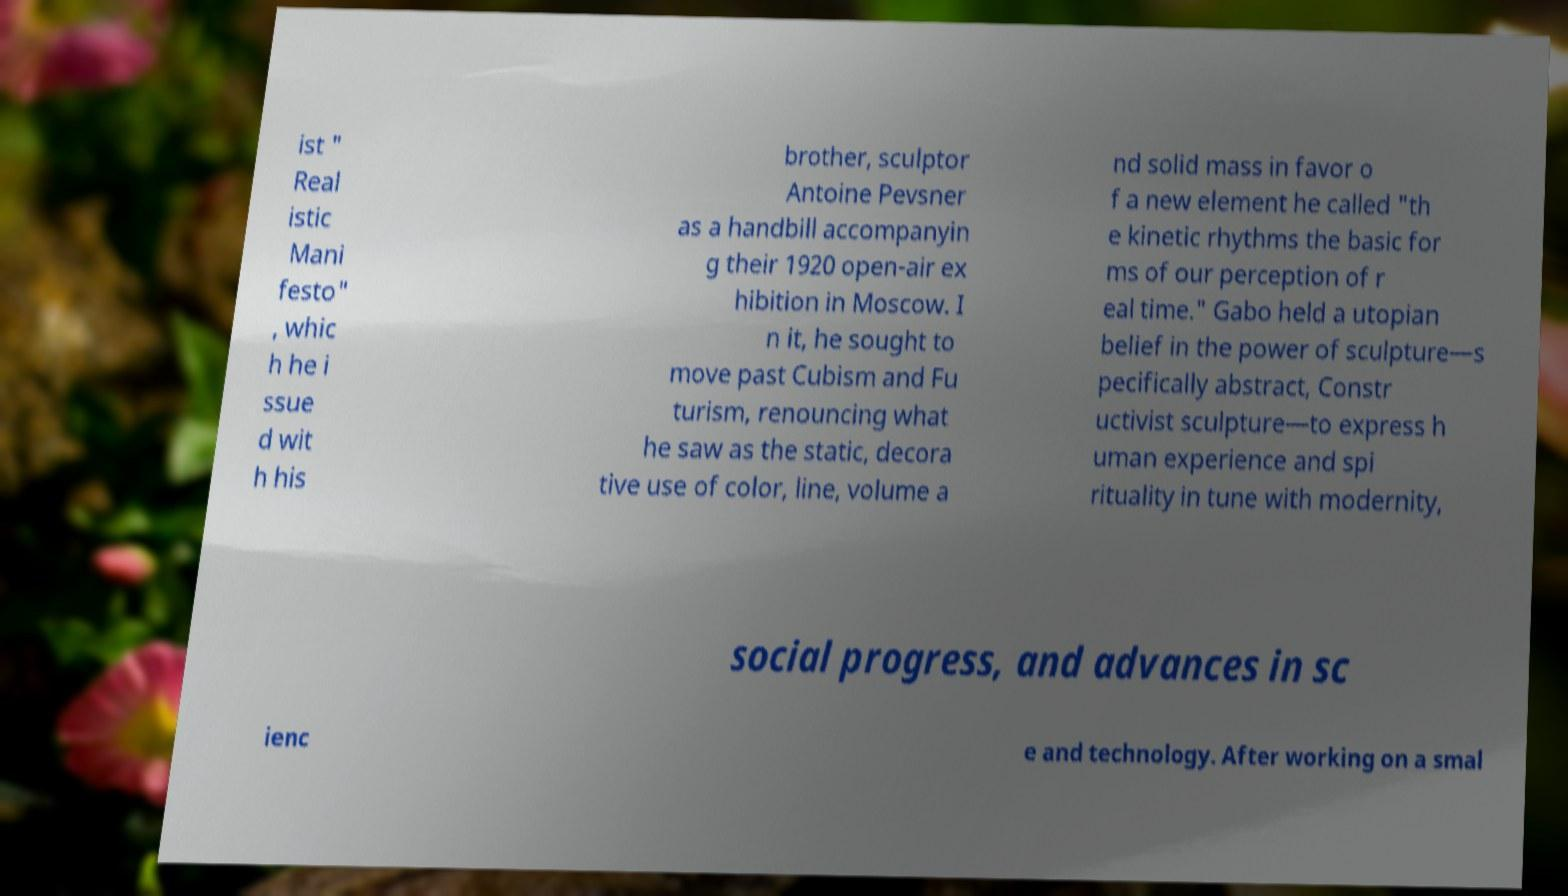Please read and relay the text visible in this image. What does it say? ist " Real istic Mani festo" , whic h he i ssue d wit h his brother, sculptor Antoine Pevsner as a handbill accompanyin g their 1920 open-air ex hibition in Moscow. I n it, he sought to move past Cubism and Fu turism, renouncing what he saw as the static, decora tive use of color, line, volume a nd solid mass in favor o f a new element he called "th e kinetic rhythms the basic for ms of our perception of r eal time." Gabo held a utopian belief in the power of sculpture—s pecifically abstract, Constr uctivist sculpture—to express h uman experience and spi rituality in tune with modernity, social progress, and advances in sc ienc e and technology. After working on a smal 